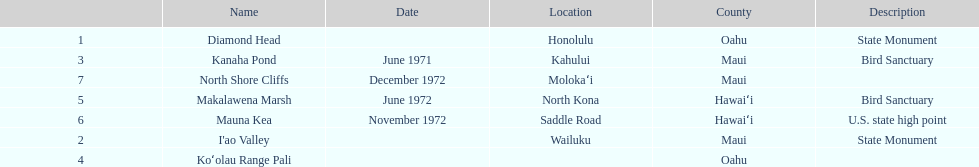Parse the full table. {'header': ['', 'Name', 'Date', 'Location', 'County', 'Description'], 'rows': [['1', 'Diamond Head', '', 'Honolulu', 'Oahu', 'State Monument'], ['3', 'Kanaha Pond', 'June 1971', 'Kahului', 'Maui', 'Bird Sanctuary'], ['7', 'North Shore Cliffs', 'December 1972', 'Molokaʻi', 'Maui', ''], ['5', 'Makalawena Marsh', 'June 1972', 'North Kona', 'Hawaiʻi', 'Bird Sanctuary'], ['6', 'Mauna Kea', 'November 1972', 'Saddle Road', 'Hawaiʻi', 'U.S. state high point'], ['2', "I'ao Valley", '', 'Wailuku', 'Maui', 'State Monument'], ['4', 'Koʻolau Range Pali', '', '', 'Oahu', '']]} What are the total number of landmarks located in maui? 3. 